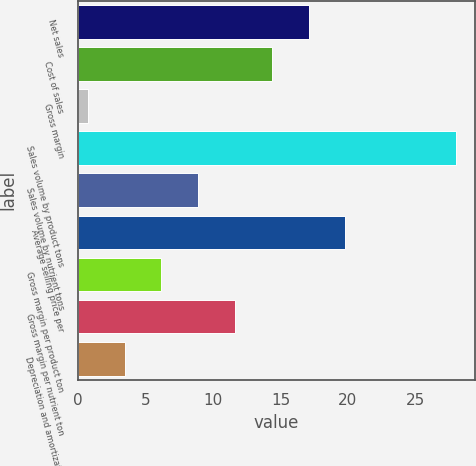Convert chart. <chart><loc_0><loc_0><loc_500><loc_500><bar_chart><fcel>Net sales<fcel>Cost of sales<fcel>Gross margin<fcel>Sales volume by product tons<fcel>Sales volume by nutrient tons<fcel>Average selling price per<fcel>Gross margin per product ton<fcel>Gross margin per nutrient ton<fcel>Depreciation and amortization<nl><fcel>17.08<fcel>14.35<fcel>0.7<fcel>28<fcel>8.89<fcel>19.81<fcel>6.16<fcel>11.62<fcel>3.43<nl></chart> 